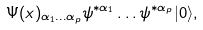Convert formula to latex. <formula><loc_0><loc_0><loc_500><loc_500>\Psi ( x ) _ { \alpha _ { 1 } \dots \alpha _ { p } } \psi ^ { * \alpha _ { 1 } } \dots \psi ^ { * \alpha _ { p } } | 0 \rangle ,</formula> 